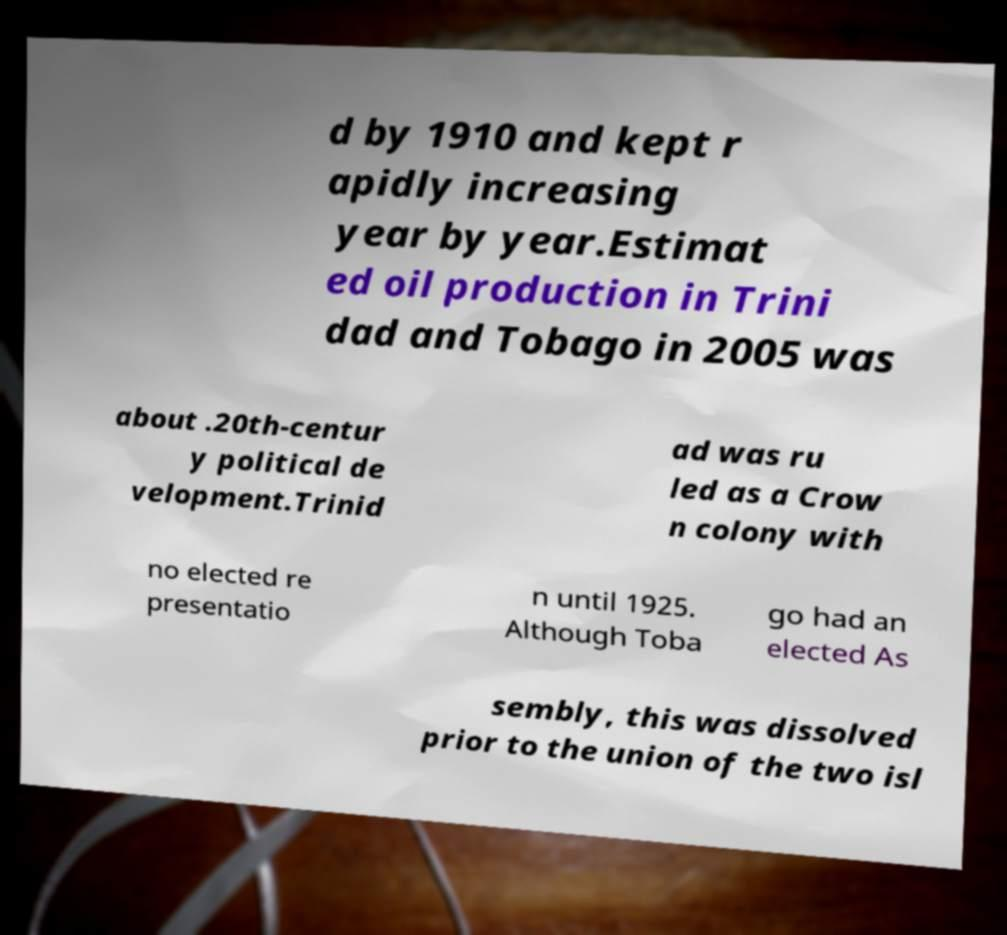I need the written content from this picture converted into text. Can you do that? d by 1910 and kept r apidly increasing year by year.Estimat ed oil production in Trini dad and Tobago in 2005 was about .20th-centur y political de velopment.Trinid ad was ru led as a Crow n colony with no elected re presentatio n until 1925. Although Toba go had an elected As sembly, this was dissolved prior to the union of the two isl 